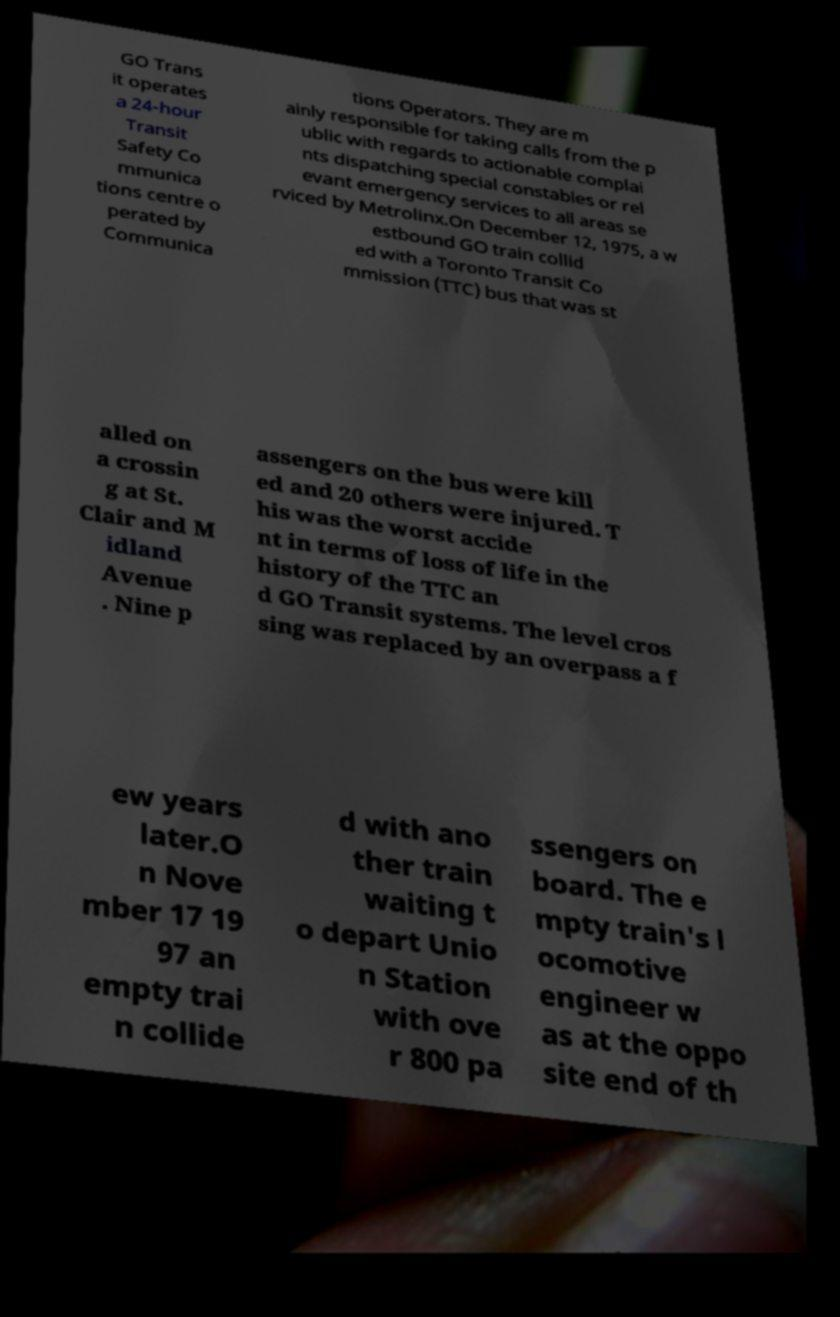Can you accurately transcribe the text from the provided image for me? GO Trans it operates a 24-hour Transit Safety Co mmunica tions centre o perated by Communica tions Operators. They are m ainly responsible for taking calls from the p ublic with regards to actionable complai nts dispatching special constables or rel evant emergency services to all areas se rviced by Metrolinx.On December 12, 1975, a w estbound GO train collid ed with a Toronto Transit Co mmission (TTC) bus that was st alled on a crossin g at St. Clair and M idland Avenue . Nine p assengers on the bus were kill ed and 20 others were injured. T his was the worst accide nt in terms of loss of life in the history of the TTC an d GO Transit systems. The level cros sing was replaced by an overpass a f ew years later.O n Nove mber 17 19 97 an empty trai n collide d with ano ther train waiting t o depart Unio n Station with ove r 800 pa ssengers on board. The e mpty train's l ocomotive engineer w as at the oppo site end of th 